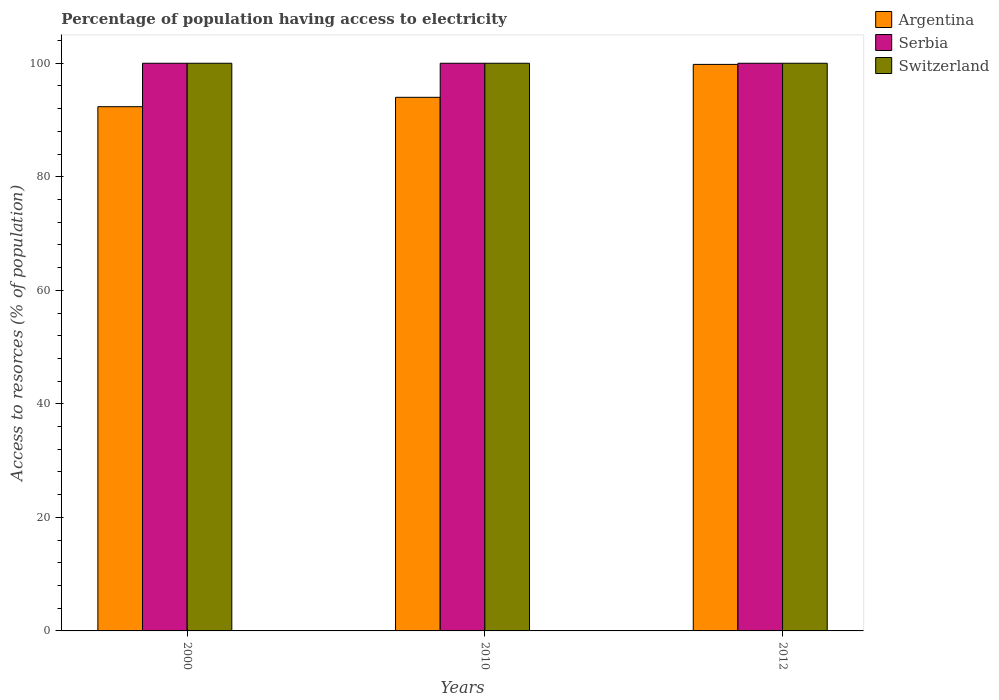How many different coloured bars are there?
Your answer should be compact. 3. How many groups of bars are there?
Your answer should be very brief. 3. Are the number of bars per tick equal to the number of legend labels?
Offer a very short reply. Yes. Are the number of bars on each tick of the X-axis equal?
Keep it short and to the point. Yes. How many bars are there on the 2nd tick from the left?
Make the answer very short. 3. What is the label of the 1st group of bars from the left?
Provide a short and direct response. 2000. In how many cases, is the number of bars for a given year not equal to the number of legend labels?
Provide a succinct answer. 0. What is the percentage of population having access to electricity in Switzerland in 2010?
Keep it short and to the point. 100. Across all years, what is the maximum percentage of population having access to electricity in Serbia?
Your response must be concise. 100. Across all years, what is the minimum percentage of population having access to electricity in Switzerland?
Your answer should be compact. 100. In which year was the percentage of population having access to electricity in Serbia maximum?
Your response must be concise. 2000. In which year was the percentage of population having access to electricity in Serbia minimum?
Your answer should be compact. 2000. What is the total percentage of population having access to electricity in Argentina in the graph?
Your answer should be compact. 286.15. What is the difference between the percentage of population having access to electricity in Serbia in 2010 and that in 2012?
Your response must be concise. 0. What is the difference between the percentage of population having access to electricity in Serbia in 2000 and the percentage of population having access to electricity in Switzerland in 2012?
Your response must be concise. 0. In the year 2000, what is the difference between the percentage of population having access to electricity in Serbia and percentage of population having access to electricity in Switzerland?
Make the answer very short. 0. Is the percentage of population having access to electricity in Switzerland in 2000 less than that in 2012?
Your answer should be very brief. No. Is the difference between the percentage of population having access to electricity in Serbia in 2000 and 2012 greater than the difference between the percentage of population having access to electricity in Switzerland in 2000 and 2012?
Ensure brevity in your answer.  No. What is the difference between the highest and the second highest percentage of population having access to electricity in Argentina?
Make the answer very short. 5.8. What does the 2nd bar from the left in 2000 represents?
Your response must be concise. Serbia. What does the 1st bar from the right in 2010 represents?
Ensure brevity in your answer.  Switzerland. Is it the case that in every year, the sum of the percentage of population having access to electricity in Switzerland and percentage of population having access to electricity in Argentina is greater than the percentage of population having access to electricity in Serbia?
Offer a terse response. Yes. How many bars are there?
Give a very brief answer. 9. Are all the bars in the graph horizontal?
Your answer should be very brief. No. Does the graph contain any zero values?
Keep it short and to the point. No. Where does the legend appear in the graph?
Your answer should be very brief. Top right. How are the legend labels stacked?
Provide a short and direct response. Vertical. What is the title of the graph?
Your answer should be compact. Percentage of population having access to electricity. Does "Italy" appear as one of the legend labels in the graph?
Your response must be concise. No. What is the label or title of the X-axis?
Keep it short and to the point. Years. What is the label or title of the Y-axis?
Your answer should be very brief. Access to resorces (% of population). What is the Access to resorces (% of population) of Argentina in 2000?
Your answer should be very brief. 92.35. What is the Access to resorces (% of population) in Argentina in 2010?
Keep it short and to the point. 94. What is the Access to resorces (% of population) in Switzerland in 2010?
Provide a short and direct response. 100. What is the Access to resorces (% of population) in Argentina in 2012?
Provide a short and direct response. 99.8. What is the Access to resorces (% of population) of Serbia in 2012?
Provide a short and direct response. 100. Across all years, what is the maximum Access to resorces (% of population) in Argentina?
Keep it short and to the point. 99.8. Across all years, what is the maximum Access to resorces (% of population) of Serbia?
Your answer should be compact. 100. Across all years, what is the maximum Access to resorces (% of population) of Switzerland?
Provide a succinct answer. 100. Across all years, what is the minimum Access to resorces (% of population) of Argentina?
Your answer should be compact. 92.35. What is the total Access to resorces (% of population) in Argentina in the graph?
Provide a succinct answer. 286.15. What is the total Access to resorces (% of population) in Serbia in the graph?
Your response must be concise. 300. What is the total Access to resorces (% of population) of Switzerland in the graph?
Ensure brevity in your answer.  300. What is the difference between the Access to resorces (% of population) of Argentina in 2000 and that in 2010?
Keep it short and to the point. -1.65. What is the difference between the Access to resorces (% of population) of Argentina in 2000 and that in 2012?
Offer a terse response. -7.45. What is the difference between the Access to resorces (% of population) of Argentina in 2010 and that in 2012?
Your response must be concise. -5.8. What is the difference between the Access to resorces (% of population) of Serbia in 2010 and that in 2012?
Provide a succinct answer. 0. What is the difference between the Access to resorces (% of population) of Switzerland in 2010 and that in 2012?
Make the answer very short. 0. What is the difference between the Access to resorces (% of population) in Argentina in 2000 and the Access to resorces (% of population) in Serbia in 2010?
Your answer should be compact. -7.65. What is the difference between the Access to resorces (% of population) in Argentina in 2000 and the Access to resorces (% of population) in Switzerland in 2010?
Keep it short and to the point. -7.65. What is the difference between the Access to resorces (% of population) in Serbia in 2000 and the Access to resorces (% of population) in Switzerland in 2010?
Provide a succinct answer. 0. What is the difference between the Access to resorces (% of population) of Argentina in 2000 and the Access to resorces (% of population) of Serbia in 2012?
Ensure brevity in your answer.  -7.65. What is the difference between the Access to resorces (% of population) of Argentina in 2000 and the Access to resorces (% of population) of Switzerland in 2012?
Your response must be concise. -7.65. What is the difference between the Access to resorces (% of population) of Serbia in 2010 and the Access to resorces (% of population) of Switzerland in 2012?
Offer a very short reply. 0. What is the average Access to resorces (% of population) in Argentina per year?
Offer a very short reply. 95.38. What is the average Access to resorces (% of population) of Serbia per year?
Your response must be concise. 100. In the year 2000, what is the difference between the Access to resorces (% of population) in Argentina and Access to resorces (% of population) in Serbia?
Your answer should be compact. -7.65. In the year 2000, what is the difference between the Access to resorces (% of population) in Argentina and Access to resorces (% of population) in Switzerland?
Make the answer very short. -7.65. In the year 2010, what is the difference between the Access to resorces (% of population) in Argentina and Access to resorces (% of population) in Serbia?
Give a very brief answer. -6. In the year 2010, what is the difference between the Access to resorces (% of population) in Argentina and Access to resorces (% of population) in Switzerland?
Your answer should be very brief. -6. In the year 2012, what is the difference between the Access to resorces (% of population) of Argentina and Access to resorces (% of population) of Serbia?
Give a very brief answer. -0.2. What is the ratio of the Access to resorces (% of population) in Argentina in 2000 to that in 2010?
Your answer should be very brief. 0.98. What is the ratio of the Access to resorces (% of population) of Switzerland in 2000 to that in 2010?
Make the answer very short. 1. What is the ratio of the Access to resorces (% of population) of Argentina in 2000 to that in 2012?
Provide a succinct answer. 0.93. What is the ratio of the Access to resorces (% of population) in Switzerland in 2000 to that in 2012?
Your answer should be very brief. 1. What is the ratio of the Access to resorces (% of population) of Argentina in 2010 to that in 2012?
Ensure brevity in your answer.  0.94. What is the ratio of the Access to resorces (% of population) of Serbia in 2010 to that in 2012?
Your answer should be compact. 1. What is the difference between the highest and the second highest Access to resorces (% of population) of Argentina?
Offer a very short reply. 5.8. What is the difference between the highest and the second highest Access to resorces (% of population) of Switzerland?
Offer a terse response. 0. What is the difference between the highest and the lowest Access to resorces (% of population) of Argentina?
Provide a short and direct response. 7.45. 